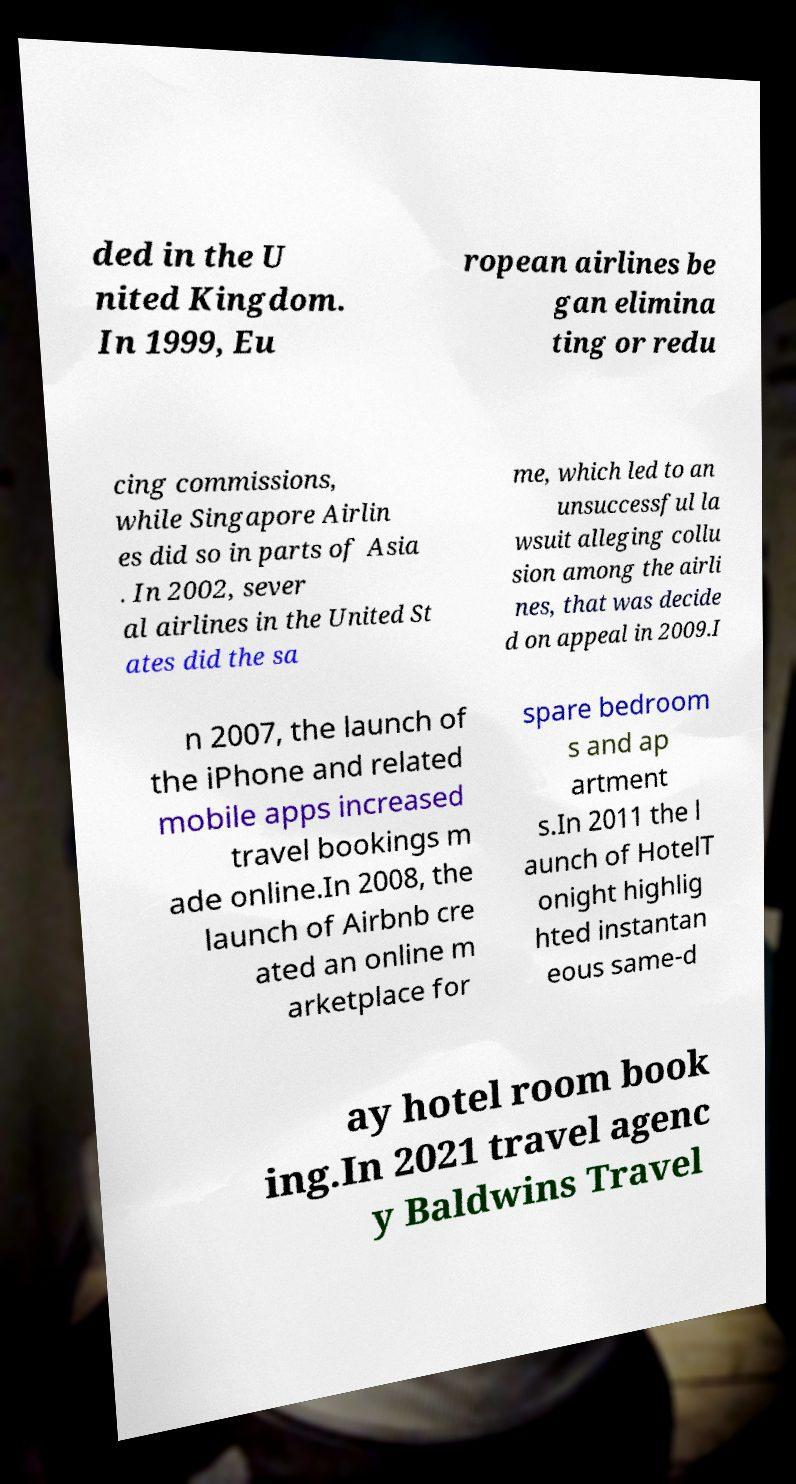For documentation purposes, I need the text within this image transcribed. Could you provide that? ded in the U nited Kingdom. In 1999, Eu ropean airlines be gan elimina ting or redu cing commissions, while Singapore Airlin es did so in parts of Asia . In 2002, sever al airlines in the United St ates did the sa me, which led to an unsuccessful la wsuit alleging collu sion among the airli nes, that was decide d on appeal in 2009.I n 2007, the launch of the iPhone and related mobile apps increased travel bookings m ade online.In 2008, the launch of Airbnb cre ated an online m arketplace for spare bedroom s and ap artment s.In 2011 the l aunch of HotelT onight highlig hted instantan eous same-d ay hotel room book ing.In 2021 travel agenc y Baldwins Travel 